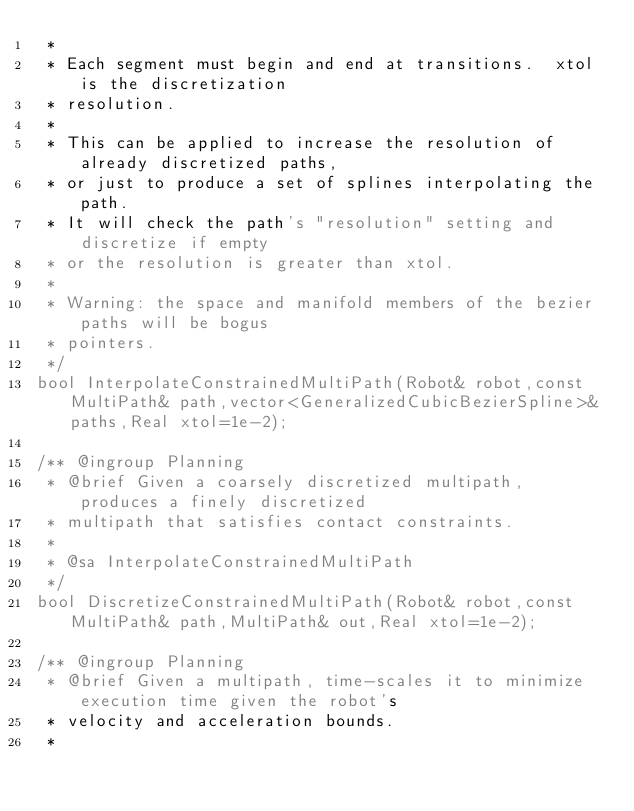Convert code to text. <code><loc_0><loc_0><loc_500><loc_500><_C_> * 
 * Each segment must begin and end at transitions.  xtol is the discretization
 * resolution.
 * 
 * This can be applied to increase the resolution of already discretized paths,
 * or just to produce a set of splines interpolating the path.
 * It will check the path's "resolution" setting and discretize if empty
 * or the resolution is greater than xtol.
 * 
 * Warning: the space and manifold members of the bezier paths will be bogus
 * pointers.
 */
bool InterpolateConstrainedMultiPath(Robot& robot,const MultiPath& path,vector<GeneralizedCubicBezierSpline>& paths,Real xtol=1e-2);

/** @ingroup Planning
 * @brief Given a coarsely discretized multipath, produces a finely discretized
 * multipath that satisfies contact constraints.
 *
 * @sa InterpolateConstrainedMultiPath
 */
bool DiscretizeConstrainedMultiPath(Robot& robot,const MultiPath& path,MultiPath& out,Real xtol=1e-2);

/** @ingroup Planning
 * @brief Given a multipath, time-scales it to minimize execution time given the robot's
 * velocity and acceleration bounds.
 *</code> 